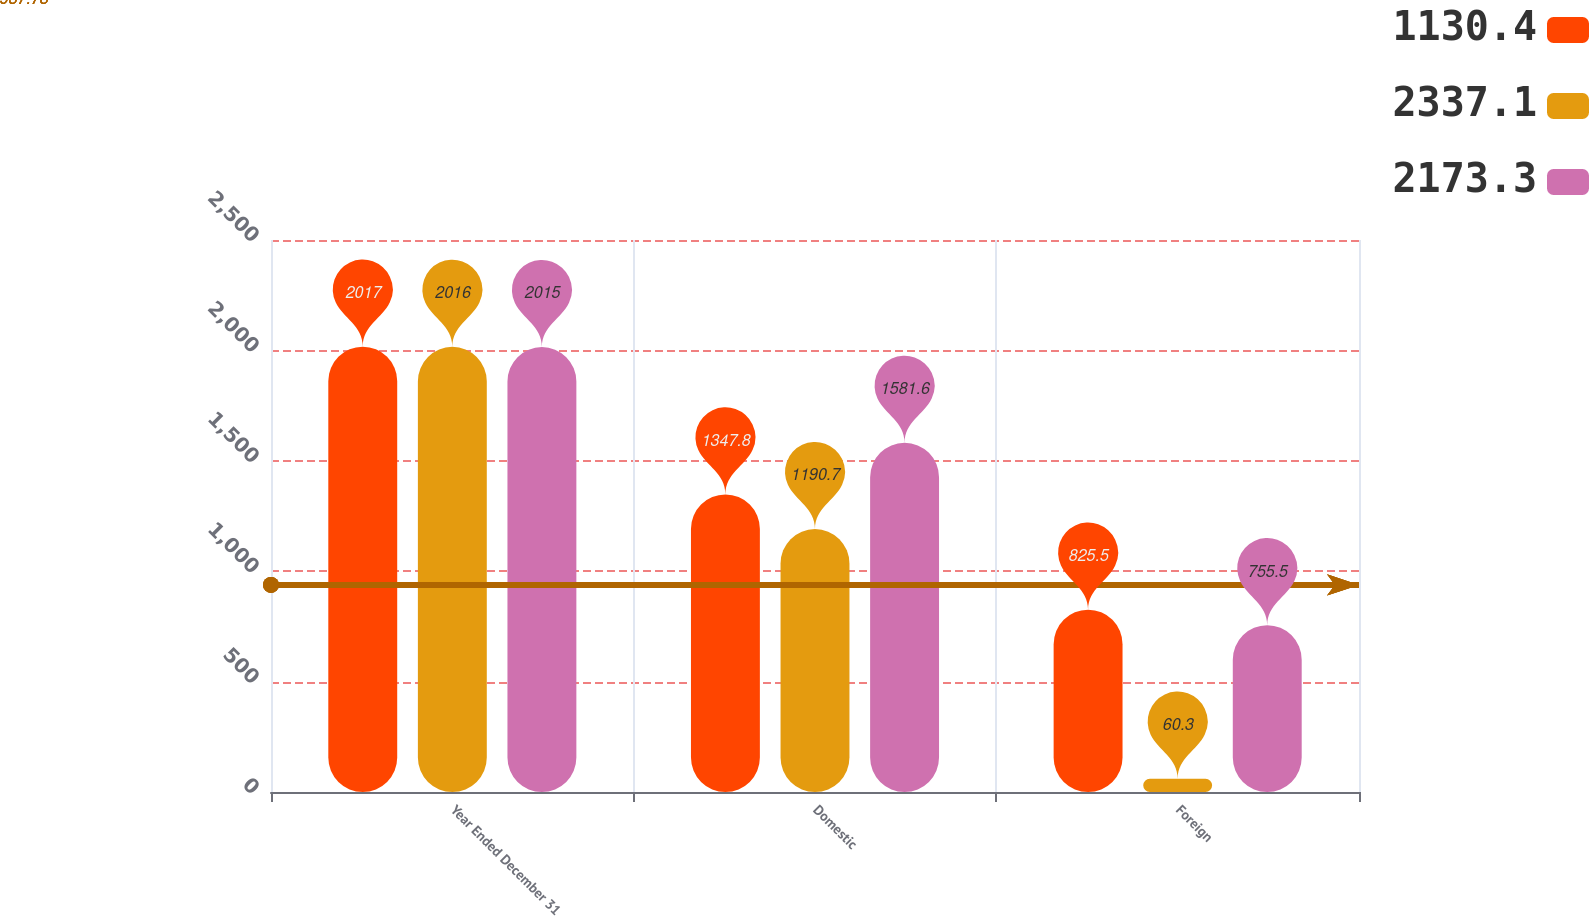Convert chart to OTSL. <chart><loc_0><loc_0><loc_500><loc_500><stacked_bar_chart><ecel><fcel>Year Ended December 31<fcel>Domestic<fcel>Foreign<nl><fcel>1130.4<fcel>2017<fcel>1347.8<fcel>825.5<nl><fcel>2337.1<fcel>2016<fcel>1190.7<fcel>60.3<nl><fcel>2173.3<fcel>2015<fcel>1581.6<fcel>755.5<nl></chart> 